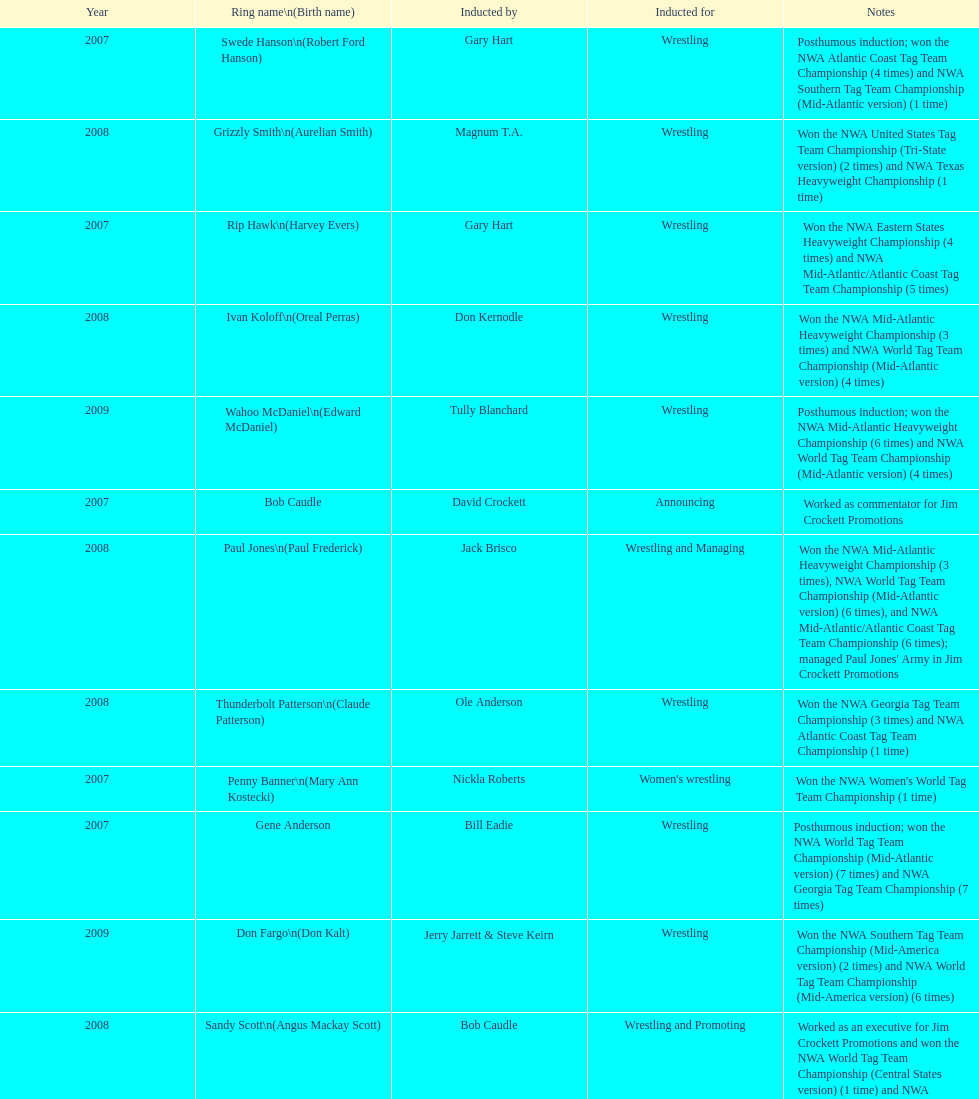Bob caudle was a commentator, who was the other one? Lance Russell. 